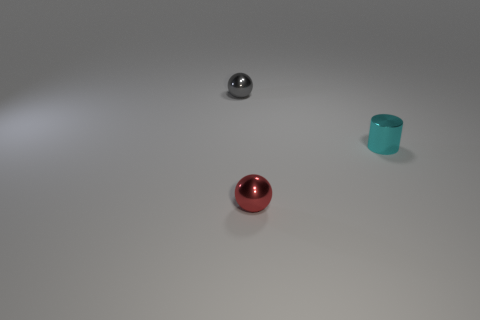There is a thing that is to the left of the small ball in front of the shiny thing behind the shiny cylinder; what is its color?
Keep it short and to the point. Gray. Are there the same number of gray spheres that are right of the small cyan object and small cyan metal objects?
Ensure brevity in your answer.  No. What number of tiny cylinders are there?
Ensure brevity in your answer.  1. How many metallic balls are both behind the small cylinder and in front of the small cyan metallic object?
Ensure brevity in your answer.  0. Is there a cylinder that has the same material as the red thing?
Offer a terse response. Yes. What is the material of the thing behind the small metal thing that is to the right of the red shiny object?
Give a very brief answer. Metal. Are there the same number of balls that are behind the tiny cyan cylinder and small metal cylinders behind the gray metal sphere?
Make the answer very short. No. Does the small gray object have the same shape as the tiny red metal object?
Your answer should be very brief. Yes. What number of tiny gray objects are the same shape as the red object?
Provide a short and direct response. 1. There is a cyan cylinder that is behind the metallic ball that is on the right side of the ball behind the small cyan metallic cylinder; how big is it?
Ensure brevity in your answer.  Small. 